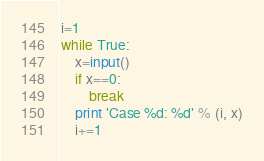<code> <loc_0><loc_0><loc_500><loc_500><_Python_>i=1
while True:
    x=input()
    if x==0:
        break
    print 'Case %d: %d' % (i, x)
    i+=1</code> 